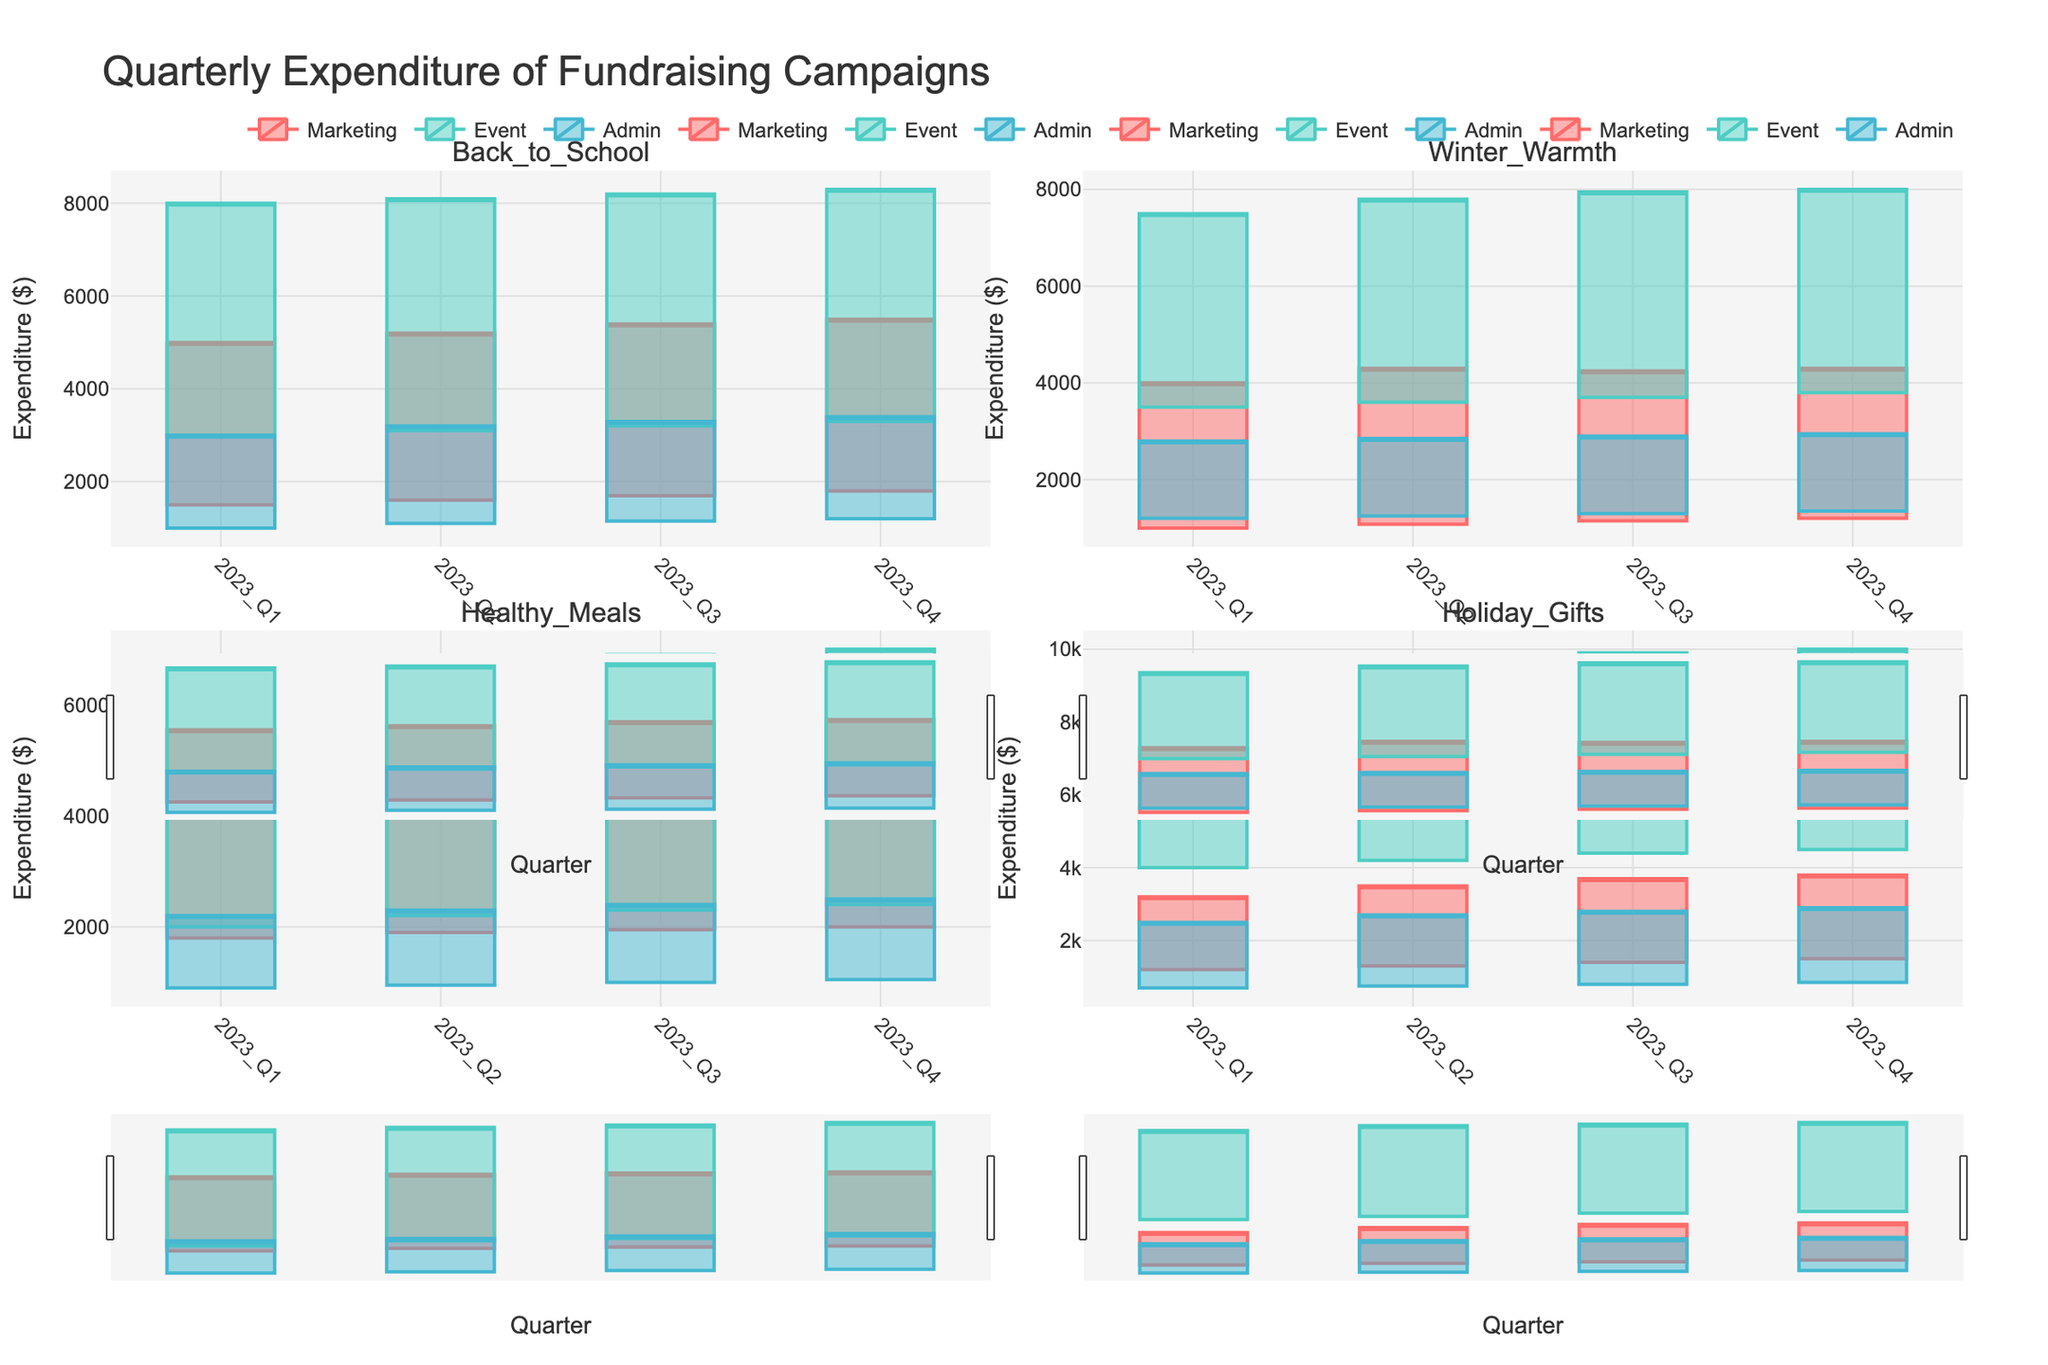What's the overall title of the figure? The overall title of the figure can be seen at the top, which is "Quarterly Expenditure of Fundraising Campaigns".
Answer: Quarterly Expenditure of Fundraising Campaigns Which expenditure category has the highest value for the "Back_to_School" campaign in 2023 Q1? Looking at the candlestick plot for "Back_to_School" in 2023 Q1, we see that the Event Costs category has the highest upper whisker value. The Event Costs' high value reaches up to $8000.
Answer: Event Costs How does the maximum expenditure on Marketing for "Healthy_Meals" change between 2023 Q1 and 2023 Q4? For "Healthy_Meals" in 2023 Q1, the highest Marketing expenditure is at $4800. In 2023 Q4, it reaches up to $5000. The difference is $5000 - $4800 = $200.
Answer: Increased by $200 Compare the range of Event Costs for "Holiday_Gifts" in 2023 Q1 to 2023 Q2. Which quarter has the wider range? In 2023 Q1, Event Costs ranges from $4000 to $9500 (9500 - 4000 = $5500). In 2023 Q2, it ranges from $4200 to $9800 (9800 - 4200 = $5600). Therefore, 2023 Q2 has a slightly wider range of Event Costs.
Answer: 2023 Q2 For the "Winter_Warmth" campaign, which quarter shows the smallest range in Administrative expenses? Examining the candlesticks for Administrative expenses in "Winter_Warmth": 
- 2023 Q1 ranges from $1200 to $2800 (1600). 
- 2023 Q2 ranges from $1250 to $2850 (1600). 
- 2023 Q3 ranges from $1300 to $2900 (1600). 
- 2023 Q4 ranges from $1350 to $2950 (1600). 
All quarters show an equal range of $1600 for Administrative expenses.
Answer: All quarters have the same range What's the average maximum expenditure on Event Costs for "Back_to_School" across all quarters shown? The maximum Event Costs for "Back_to_School" are: 
- Q1: $8000 
- Q2: $8100 
- Q3: $8200 
- Q4: $8300. 
The average is $(8000 + 8100 + 8200 + 8300) / 4 = 8150.
Answer: $8,150 Which expense category has the least variation in the "Holiday_Gifts" campaign for any quarter in 2023? Analyzing the candlesticks for "Holiday_Gifts", we note that in each quarter:
- Q1: Marketing (1200-3200), Event (4000-9500), Admin (700-2500).
- Q2: Marketing (1300-3500), Event (4200-9800), Admin (750-2700).
- Q3: Marketing (1400-3700), Event (4400-9900), Admin (800-2800).
- Q4: Marketing (1500-3800), Event (4500-10000), Admin (850-2900).
The Admin category consistently has the smallest variation.
Answer: Administrative expenses Between which two quarters did the Marketing expenditure for "Winter_Warmth" have the greatest increase? Examining "Winter_Warmth" for Marketing:
- Q1: $1000 to $4000.
- Q2: $1080 to $4300 (300).
- Q3: $1150 to $4250 (250).
- Q4: $1200 to $4300 (300).
The greatest increase in Marketing expenditure happens between Q3 ($1150-$4250) and Q4 ($1200-$4300), where it moves from $1150 to $1200 and from $4250 to $4300 ($300).
Answer: Q2 to Q3 